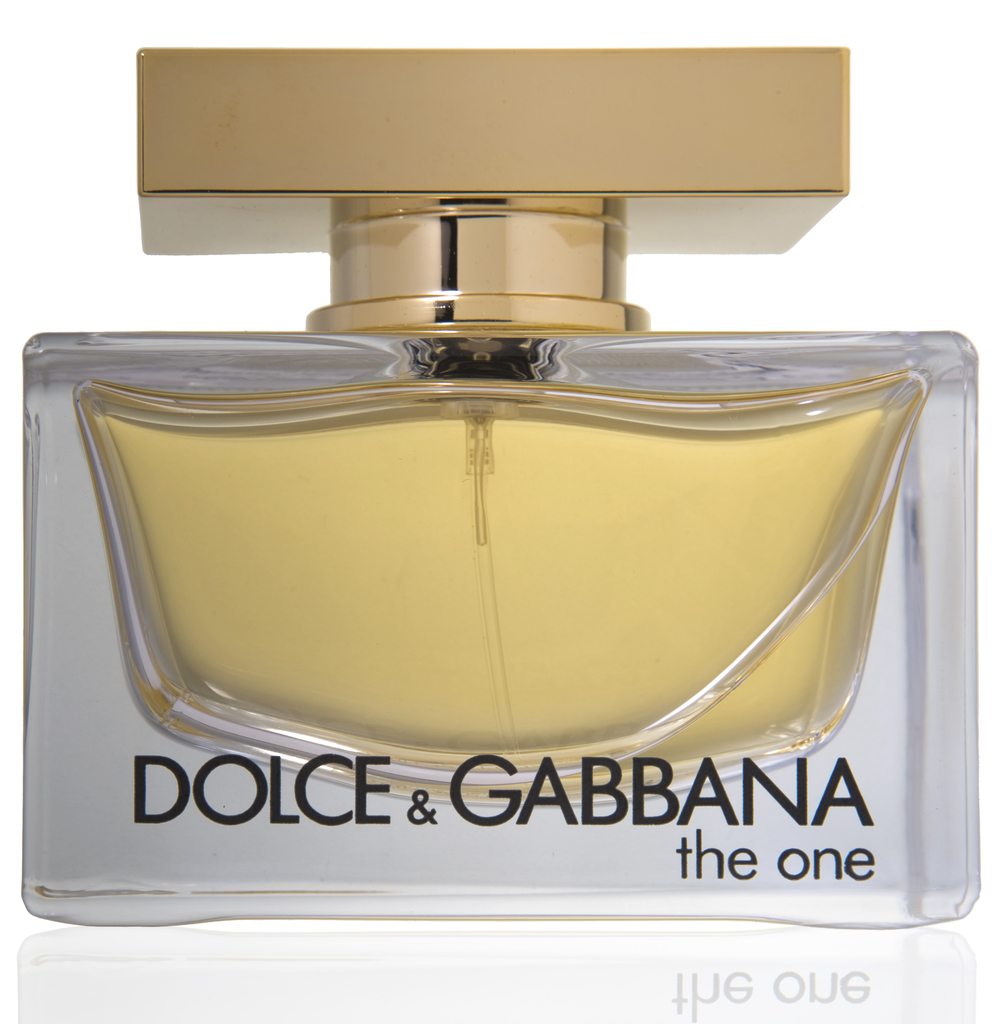Is there any significance to the background of the perfume advertisement? The white background in the image serves a specific purpose: it creates a contrast that highlights the perfume bottle, drawing the viewer’s attention directly to it. This minimalist approach in advertising is effective as it cuts out distractions and focuses on the product itself, suggesting clarity and simplicity. Moreover, the clean background might subtly imply that the fragrance is crisp, modern, and suitable for everyday elegance, aligning it seamlessly with contemporary lifestyles. 